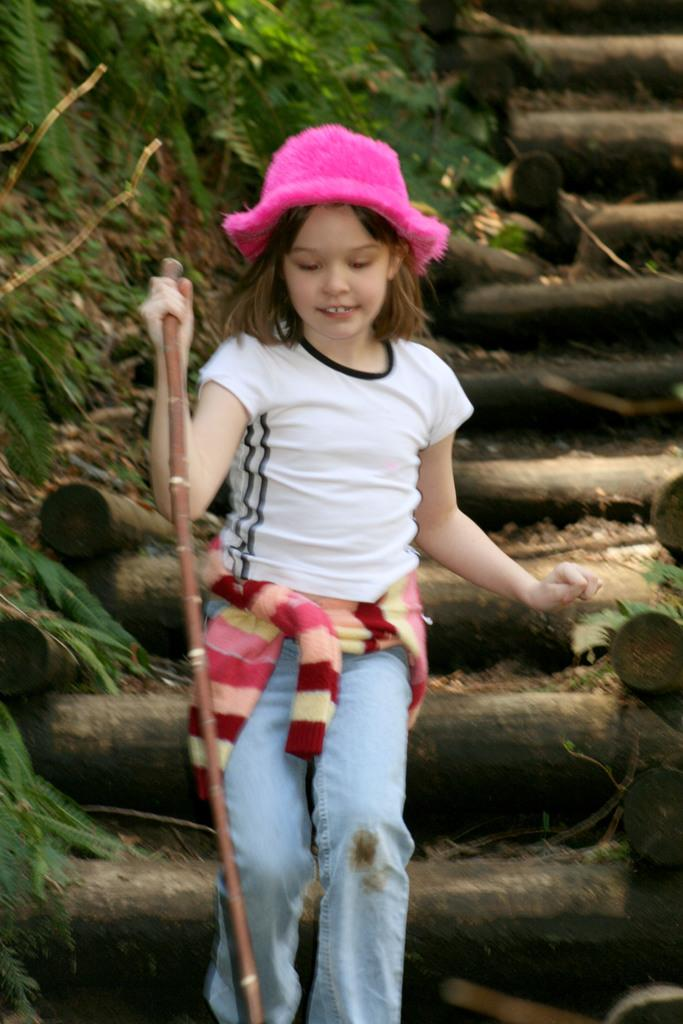Who is the main subject in the image? There is a girl in the image. What is the girl holding in the image? The girl is holding a stick. Where is the girl located in the image? The girl is in the middle of the image. What can be seen in the background of the image? There are stairs in the background of the image. Who is the friend that the girl is talking to in the image? There is no friend visible in the image, and the girl is not shown talking to anyone. Who is the creator of the stick that the girl is holding? The facts provided do not mention the creator of the stick, and it is not relevant to the image. 